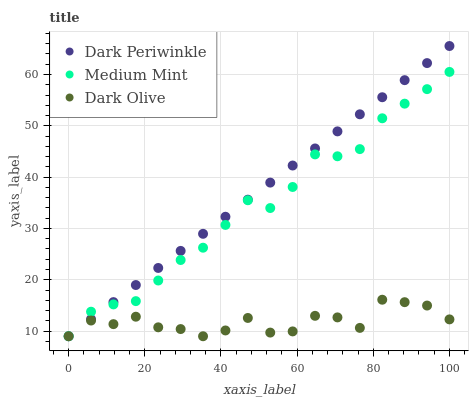Does Dark Olive have the minimum area under the curve?
Answer yes or no. Yes. Does Dark Periwinkle have the maximum area under the curve?
Answer yes or no. Yes. Does Dark Periwinkle have the minimum area under the curve?
Answer yes or no. No. Does Dark Olive have the maximum area under the curve?
Answer yes or no. No. Is Dark Periwinkle the smoothest?
Answer yes or no. Yes. Is Dark Olive the roughest?
Answer yes or no. Yes. Is Dark Olive the smoothest?
Answer yes or no. No. Is Dark Periwinkle the roughest?
Answer yes or no. No. Does Medium Mint have the lowest value?
Answer yes or no. Yes. Does Dark Periwinkle have the highest value?
Answer yes or no. Yes. Does Dark Olive have the highest value?
Answer yes or no. No. Does Dark Periwinkle intersect Medium Mint?
Answer yes or no. Yes. Is Dark Periwinkle less than Medium Mint?
Answer yes or no. No. Is Dark Periwinkle greater than Medium Mint?
Answer yes or no. No. 